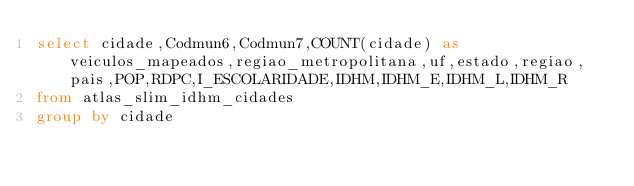<code> <loc_0><loc_0><loc_500><loc_500><_SQL_>select cidade,Codmun6,Codmun7,COUNT(cidade) as veiculos_mapeados,regiao_metropolitana,uf,estado,regiao,pais,POP,RDPC,I_ESCOLARIDADE,IDHM,IDHM_E,IDHM_L,IDHM_R
from atlas_slim_idhm_cidades
group by cidade</code> 